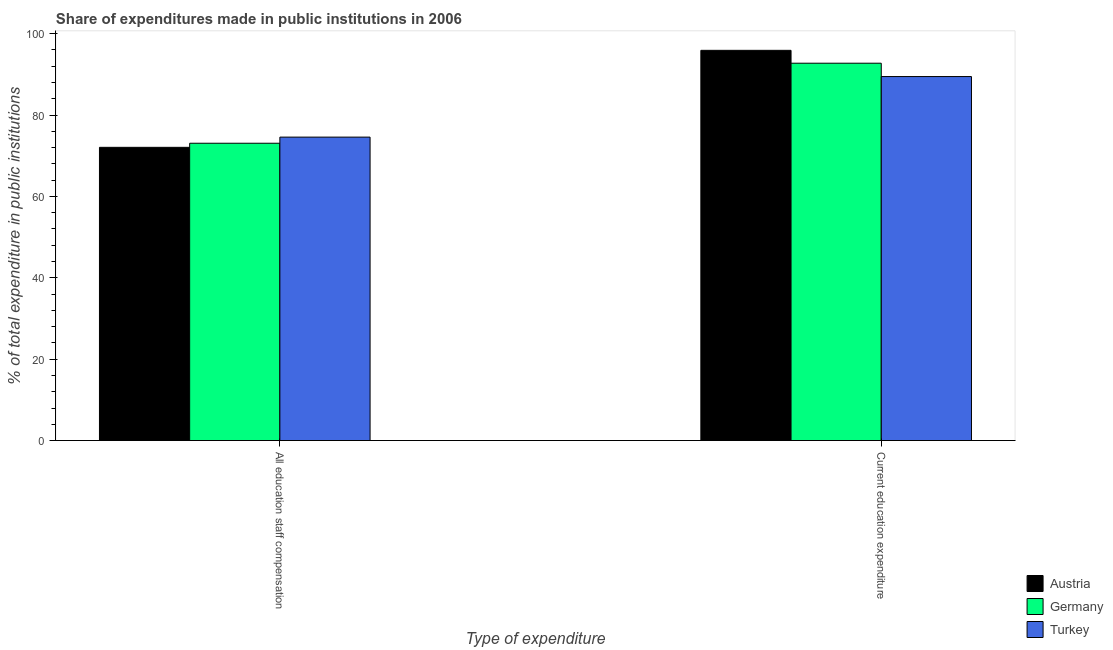How many different coloured bars are there?
Keep it short and to the point. 3. Are the number of bars per tick equal to the number of legend labels?
Your answer should be compact. Yes. Are the number of bars on each tick of the X-axis equal?
Your response must be concise. Yes. How many bars are there on the 2nd tick from the left?
Your answer should be very brief. 3. How many bars are there on the 1st tick from the right?
Provide a succinct answer. 3. What is the label of the 1st group of bars from the left?
Ensure brevity in your answer.  All education staff compensation. What is the expenditure in staff compensation in Germany?
Ensure brevity in your answer.  73.06. Across all countries, what is the maximum expenditure in staff compensation?
Your answer should be compact. 74.57. Across all countries, what is the minimum expenditure in education?
Your answer should be very brief. 89.45. What is the total expenditure in staff compensation in the graph?
Provide a short and direct response. 219.68. What is the difference between the expenditure in education in Germany and that in Turkey?
Provide a short and direct response. 3.28. What is the difference between the expenditure in staff compensation in Germany and the expenditure in education in Austria?
Provide a succinct answer. -22.83. What is the average expenditure in staff compensation per country?
Keep it short and to the point. 73.23. What is the difference between the expenditure in education and expenditure in staff compensation in Austria?
Your response must be concise. 23.83. What is the ratio of the expenditure in staff compensation in Turkey to that in Austria?
Your answer should be compact. 1.03. Is the expenditure in staff compensation in Germany less than that in Austria?
Your response must be concise. No. In how many countries, is the expenditure in staff compensation greater than the average expenditure in staff compensation taken over all countries?
Offer a very short reply. 1. How many bars are there?
Your response must be concise. 6. Are the values on the major ticks of Y-axis written in scientific E-notation?
Your answer should be very brief. No. Does the graph contain any zero values?
Make the answer very short. No. Does the graph contain grids?
Offer a very short reply. No. Where does the legend appear in the graph?
Give a very brief answer. Bottom right. How are the legend labels stacked?
Offer a very short reply. Vertical. What is the title of the graph?
Offer a terse response. Share of expenditures made in public institutions in 2006. Does "Samoa" appear as one of the legend labels in the graph?
Provide a succinct answer. No. What is the label or title of the X-axis?
Ensure brevity in your answer.  Type of expenditure. What is the label or title of the Y-axis?
Ensure brevity in your answer.  % of total expenditure in public institutions. What is the % of total expenditure in public institutions in Austria in All education staff compensation?
Your answer should be very brief. 72.06. What is the % of total expenditure in public institutions of Germany in All education staff compensation?
Give a very brief answer. 73.06. What is the % of total expenditure in public institutions in Turkey in All education staff compensation?
Keep it short and to the point. 74.57. What is the % of total expenditure in public institutions in Austria in Current education expenditure?
Offer a terse response. 95.89. What is the % of total expenditure in public institutions in Germany in Current education expenditure?
Provide a short and direct response. 92.73. What is the % of total expenditure in public institutions of Turkey in Current education expenditure?
Give a very brief answer. 89.45. Across all Type of expenditure, what is the maximum % of total expenditure in public institutions in Austria?
Make the answer very short. 95.89. Across all Type of expenditure, what is the maximum % of total expenditure in public institutions in Germany?
Your answer should be very brief. 92.73. Across all Type of expenditure, what is the maximum % of total expenditure in public institutions of Turkey?
Provide a succinct answer. 89.45. Across all Type of expenditure, what is the minimum % of total expenditure in public institutions in Austria?
Provide a succinct answer. 72.06. Across all Type of expenditure, what is the minimum % of total expenditure in public institutions of Germany?
Give a very brief answer. 73.06. Across all Type of expenditure, what is the minimum % of total expenditure in public institutions in Turkey?
Keep it short and to the point. 74.57. What is the total % of total expenditure in public institutions of Austria in the graph?
Offer a very short reply. 167.94. What is the total % of total expenditure in public institutions of Germany in the graph?
Make the answer very short. 165.79. What is the total % of total expenditure in public institutions of Turkey in the graph?
Provide a short and direct response. 164.01. What is the difference between the % of total expenditure in public institutions of Austria in All education staff compensation and that in Current education expenditure?
Your answer should be very brief. -23.83. What is the difference between the % of total expenditure in public institutions in Germany in All education staff compensation and that in Current education expenditure?
Provide a short and direct response. -19.67. What is the difference between the % of total expenditure in public institutions of Turkey in All education staff compensation and that in Current education expenditure?
Keep it short and to the point. -14.88. What is the difference between the % of total expenditure in public institutions in Austria in All education staff compensation and the % of total expenditure in public institutions in Germany in Current education expenditure?
Ensure brevity in your answer.  -20.67. What is the difference between the % of total expenditure in public institutions of Austria in All education staff compensation and the % of total expenditure in public institutions of Turkey in Current education expenditure?
Provide a short and direct response. -17.39. What is the difference between the % of total expenditure in public institutions in Germany in All education staff compensation and the % of total expenditure in public institutions in Turkey in Current education expenditure?
Provide a succinct answer. -16.39. What is the average % of total expenditure in public institutions in Austria per Type of expenditure?
Give a very brief answer. 83.97. What is the average % of total expenditure in public institutions in Germany per Type of expenditure?
Your answer should be compact. 82.89. What is the average % of total expenditure in public institutions in Turkey per Type of expenditure?
Give a very brief answer. 82.01. What is the difference between the % of total expenditure in public institutions of Austria and % of total expenditure in public institutions of Germany in All education staff compensation?
Provide a succinct answer. -1. What is the difference between the % of total expenditure in public institutions in Austria and % of total expenditure in public institutions in Turkey in All education staff compensation?
Keep it short and to the point. -2.51. What is the difference between the % of total expenditure in public institutions of Germany and % of total expenditure in public institutions of Turkey in All education staff compensation?
Make the answer very short. -1.51. What is the difference between the % of total expenditure in public institutions in Austria and % of total expenditure in public institutions in Germany in Current education expenditure?
Provide a succinct answer. 3.16. What is the difference between the % of total expenditure in public institutions of Austria and % of total expenditure in public institutions of Turkey in Current education expenditure?
Keep it short and to the point. 6.44. What is the difference between the % of total expenditure in public institutions of Germany and % of total expenditure in public institutions of Turkey in Current education expenditure?
Ensure brevity in your answer.  3.28. What is the ratio of the % of total expenditure in public institutions in Austria in All education staff compensation to that in Current education expenditure?
Offer a very short reply. 0.75. What is the ratio of the % of total expenditure in public institutions of Germany in All education staff compensation to that in Current education expenditure?
Keep it short and to the point. 0.79. What is the ratio of the % of total expenditure in public institutions in Turkey in All education staff compensation to that in Current education expenditure?
Provide a short and direct response. 0.83. What is the difference between the highest and the second highest % of total expenditure in public institutions of Austria?
Provide a succinct answer. 23.83. What is the difference between the highest and the second highest % of total expenditure in public institutions in Germany?
Your answer should be very brief. 19.67. What is the difference between the highest and the second highest % of total expenditure in public institutions in Turkey?
Ensure brevity in your answer.  14.88. What is the difference between the highest and the lowest % of total expenditure in public institutions of Austria?
Give a very brief answer. 23.83. What is the difference between the highest and the lowest % of total expenditure in public institutions in Germany?
Offer a terse response. 19.67. What is the difference between the highest and the lowest % of total expenditure in public institutions in Turkey?
Give a very brief answer. 14.88. 